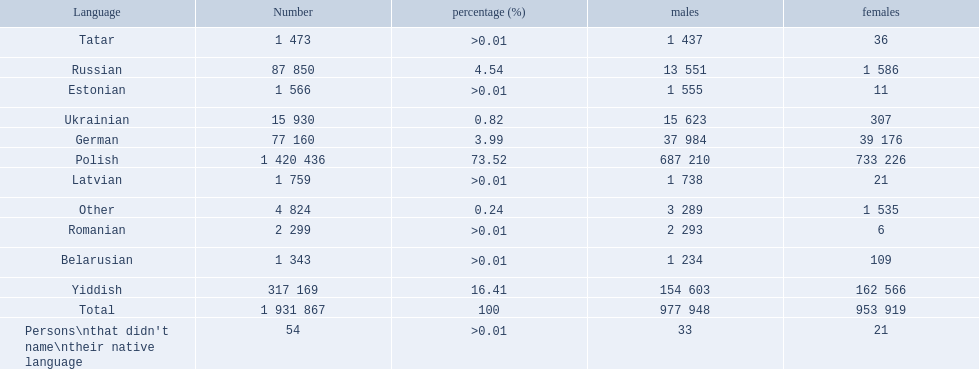What are all of the languages Polish, Yiddish, Russian, German, Ukrainian, Romanian, Latvian, Estonian, Tatar, Belarusian, Other, Persons\nthat didn't name\ntheir native language. What was the percentage of each? 73.52, 16.41, 4.54, 3.99, 0.82, >0.01, >0.01, >0.01, >0.01, >0.01, 0.24, >0.01. Which languages had a >0.01	 percentage? Romanian, Latvian, Estonian, Tatar, Belarusian. And of those, which is listed first? Romanian. 